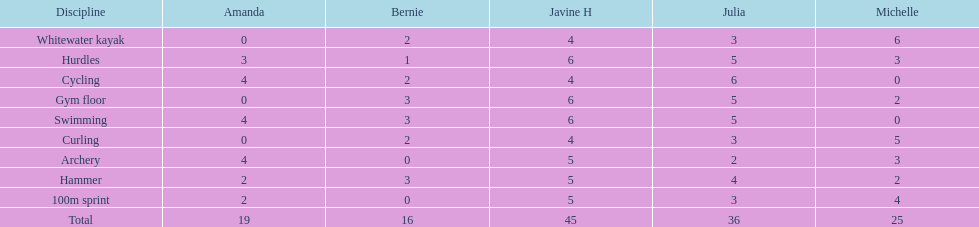Would you be able to parse every entry in this table? {'header': ['Discipline', 'Amanda', 'Bernie', 'Javine H', 'Julia', 'Michelle'], 'rows': [['Whitewater kayak', '0', '2', '4', '3', '6'], ['Hurdles', '3', '1', '6', '5', '3'], ['Cycling', '4', '2', '4', '6', '0'], ['Gym floor', '0', '3', '6', '5', '2'], ['Swimming', '4', '3', '6', '5', '0'], ['Curling', '0', '2', '4', '3', '5'], ['Archery', '4', '0', '5', '2', '3'], ['Hammer', '2', '3', '5', '4', '2'], ['100m sprint', '2', '0', '5', '3', '4'], ['Total', '19', '16', '45', '36', '25']]} Who had her best score in cycling? Julia. 